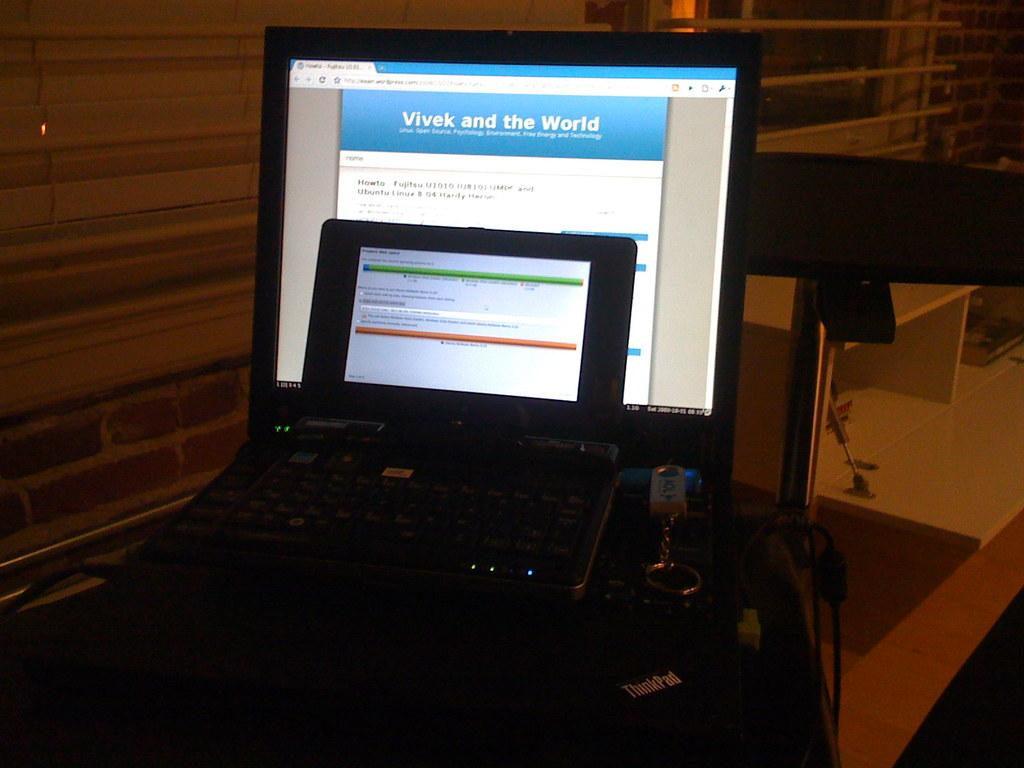<image>
Render a clear and concise summary of the photo. A computer monitor displaying a title that reads "Vivek and the world". 